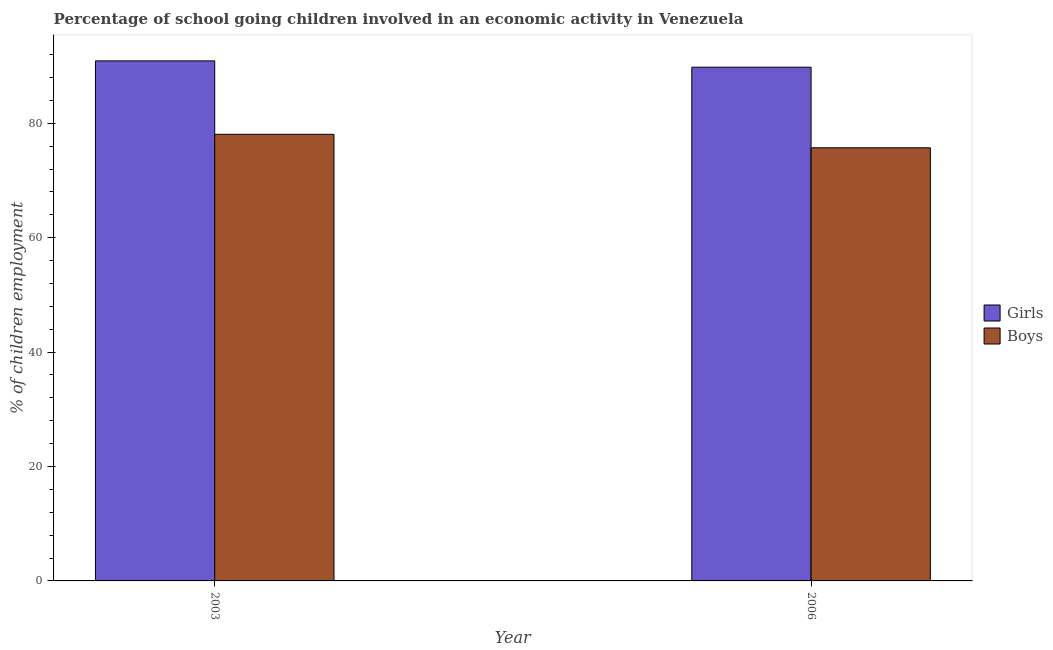How many groups of bars are there?
Provide a short and direct response. 2. Are the number of bars per tick equal to the number of legend labels?
Offer a terse response. Yes. Are the number of bars on each tick of the X-axis equal?
Provide a succinct answer. Yes. How many bars are there on the 2nd tick from the left?
Your response must be concise. 2. In how many cases, is the number of bars for a given year not equal to the number of legend labels?
Make the answer very short. 0. What is the percentage of school going boys in 2006?
Ensure brevity in your answer.  75.71. Across all years, what is the maximum percentage of school going boys?
Ensure brevity in your answer.  78.07. Across all years, what is the minimum percentage of school going girls?
Your response must be concise. 89.81. In which year was the percentage of school going girls maximum?
Provide a succinct answer. 2003. In which year was the percentage of school going boys minimum?
Ensure brevity in your answer.  2006. What is the total percentage of school going boys in the graph?
Provide a succinct answer. 153.78. What is the difference between the percentage of school going boys in 2003 and that in 2006?
Keep it short and to the point. 2.36. What is the difference between the percentage of school going girls in 2006 and the percentage of school going boys in 2003?
Offer a very short reply. -1.1. What is the average percentage of school going boys per year?
Your answer should be compact. 76.89. In the year 2003, what is the difference between the percentage of school going girls and percentage of school going boys?
Give a very brief answer. 0. What is the ratio of the percentage of school going girls in 2003 to that in 2006?
Your response must be concise. 1.01. Is the percentage of school going girls in 2003 less than that in 2006?
Provide a succinct answer. No. What does the 2nd bar from the left in 2003 represents?
Give a very brief answer. Boys. What does the 2nd bar from the right in 2003 represents?
Offer a very short reply. Girls. How many years are there in the graph?
Keep it short and to the point. 2. Are the values on the major ticks of Y-axis written in scientific E-notation?
Make the answer very short. No. Does the graph contain grids?
Keep it short and to the point. No. Where does the legend appear in the graph?
Give a very brief answer. Center right. How many legend labels are there?
Offer a terse response. 2. What is the title of the graph?
Provide a short and direct response. Percentage of school going children involved in an economic activity in Venezuela. Does "Quasi money growth" appear as one of the legend labels in the graph?
Provide a short and direct response. No. What is the label or title of the Y-axis?
Give a very brief answer. % of children employment. What is the % of children employment of Girls in 2003?
Your answer should be compact. 90.91. What is the % of children employment of Boys in 2003?
Keep it short and to the point. 78.07. What is the % of children employment in Girls in 2006?
Your answer should be compact. 89.81. What is the % of children employment of Boys in 2006?
Offer a very short reply. 75.71. Across all years, what is the maximum % of children employment in Girls?
Your answer should be compact. 90.91. Across all years, what is the maximum % of children employment in Boys?
Offer a very short reply. 78.07. Across all years, what is the minimum % of children employment of Girls?
Keep it short and to the point. 89.81. Across all years, what is the minimum % of children employment in Boys?
Offer a terse response. 75.71. What is the total % of children employment of Girls in the graph?
Provide a succinct answer. 180.72. What is the total % of children employment in Boys in the graph?
Offer a very short reply. 153.78. What is the difference between the % of children employment of Girls in 2003 and that in 2006?
Your answer should be very brief. 1.1. What is the difference between the % of children employment of Boys in 2003 and that in 2006?
Ensure brevity in your answer.  2.36. What is the difference between the % of children employment of Girls in 2003 and the % of children employment of Boys in 2006?
Your answer should be very brief. 15.2. What is the average % of children employment of Girls per year?
Ensure brevity in your answer.  90.36. What is the average % of children employment of Boys per year?
Keep it short and to the point. 76.89. In the year 2003, what is the difference between the % of children employment in Girls and % of children employment in Boys?
Give a very brief answer. 12.84. In the year 2006, what is the difference between the % of children employment in Girls and % of children employment in Boys?
Offer a very short reply. 14.09. What is the ratio of the % of children employment in Girls in 2003 to that in 2006?
Make the answer very short. 1.01. What is the ratio of the % of children employment in Boys in 2003 to that in 2006?
Your answer should be compact. 1.03. What is the difference between the highest and the second highest % of children employment of Girls?
Offer a terse response. 1.1. What is the difference between the highest and the second highest % of children employment in Boys?
Make the answer very short. 2.36. What is the difference between the highest and the lowest % of children employment of Girls?
Ensure brevity in your answer.  1.1. What is the difference between the highest and the lowest % of children employment of Boys?
Make the answer very short. 2.36. 